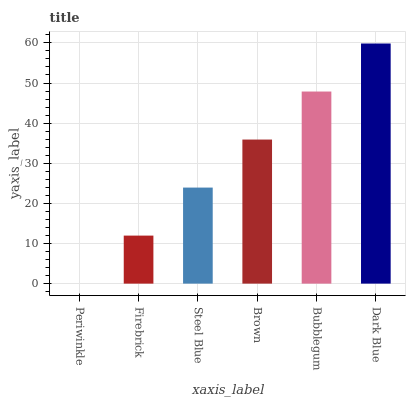Is Periwinkle the minimum?
Answer yes or no. Yes. Is Dark Blue the maximum?
Answer yes or no. Yes. Is Firebrick the minimum?
Answer yes or no. No. Is Firebrick the maximum?
Answer yes or no. No. Is Firebrick greater than Periwinkle?
Answer yes or no. Yes. Is Periwinkle less than Firebrick?
Answer yes or no. Yes. Is Periwinkle greater than Firebrick?
Answer yes or no. No. Is Firebrick less than Periwinkle?
Answer yes or no. No. Is Brown the high median?
Answer yes or no. Yes. Is Steel Blue the low median?
Answer yes or no. Yes. Is Dark Blue the high median?
Answer yes or no. No. Is Firebrick the low median?
Answer yes or no. No. 